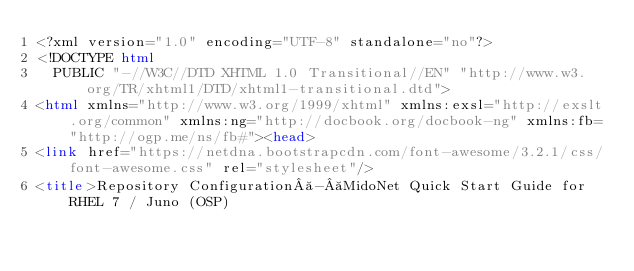Convert code to text. <code><loc_0><loc_0><loc_500><loc_500><_HTML_><?xml version="1.0" encoding="UTF-8" standalone="no"?>
<!DOCTYPE html
  PUBLIC "-//W3C//DTD XHTML 1.0 Transitional//EN" "http://www.w3.org/TR/xhtml1/DTD/xhtml1-transitional.dtd">
<html xmlns="http://www.w3.org/1999/xhtml" xmlns:exsl="http://exslt.org/common" xmlns:ng="http://docbook.org/docbook-ng" xmlns:fb="http://ogp.me/ns/fb#"><head>
<link href="https://netdna.bootstrapcdn.com/font-awesome/3.2.1/css/font-awesome.css" rel="stylesheet"/>
<title>Repository Configuration - MidoNet Quick Start Guide for RHEL 7 / Juno (OSP)</code> 